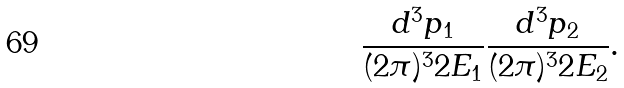<formula> <loc_0><loc_0><loc_500><loc_500>\frac { d ^ { 3 } p _ { 1 } } { ( 2 \pi ) ^ { 3 } 2 E _ { 1 } } \frac { d ^ { 3 } p _ { 2 } } { ( 2 \pi ) ^ { 3 } 2 E _ { 2 } } .</formula> 